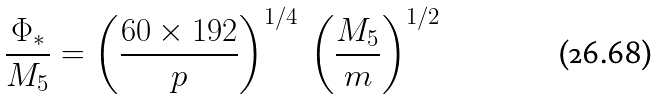Convert formula to latex. <formula><loc_0><loc_0><loc_500><loc_500>\frac { \Phi _ { * } } { M _ { 5 } } = \left ( \frac { 6 0 \times 1 9 2 } { p } \right ) ^ { 1 / 4 } \, \left ( \frac { M _ { 5 } } { m } \right ) ^ { 1 / 2 }</formula> 